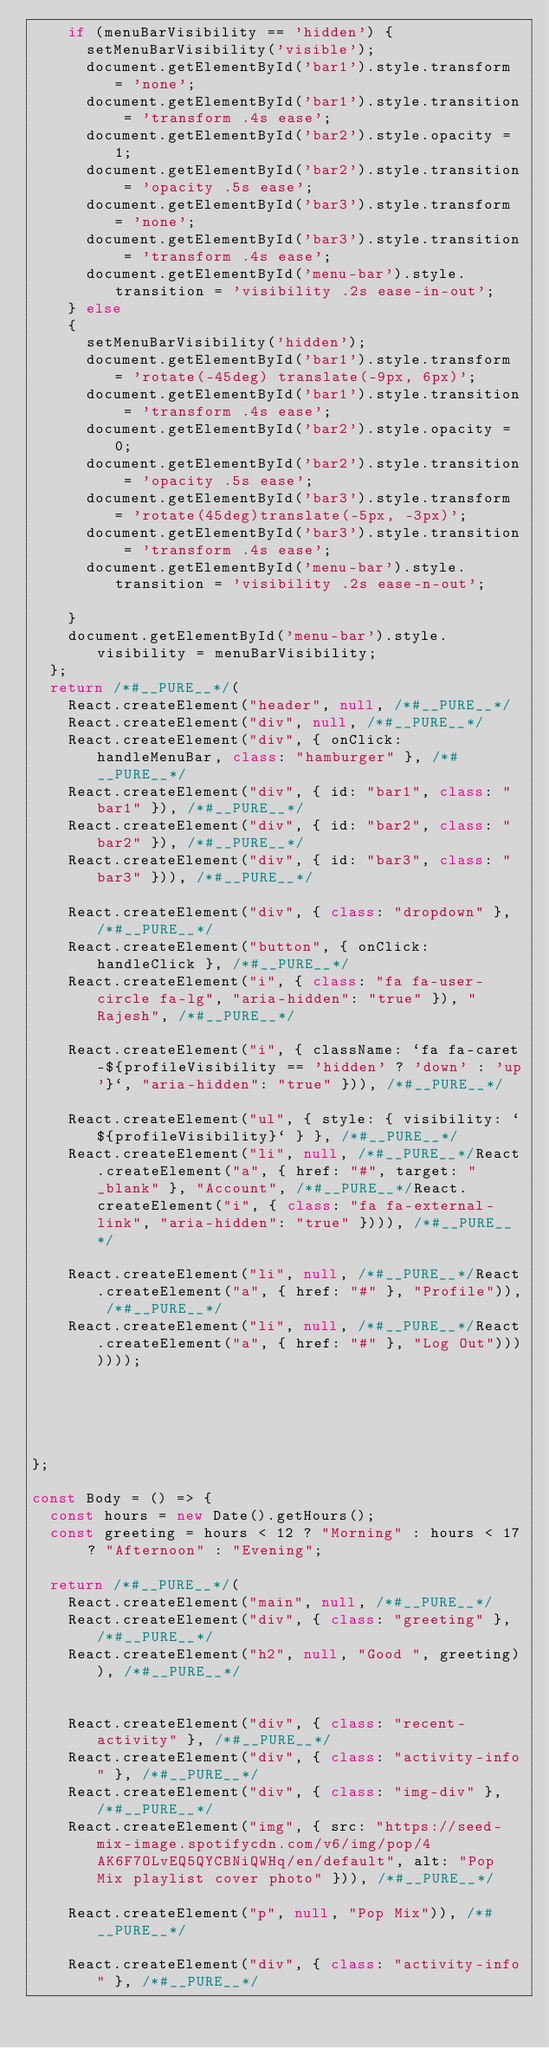Convert code to text. <code><loc_0><loc_0><loc_500><loc_500><_JavaScript_>    if (menuBarVisibility == 'hidden') {
      setMenuBarVisibility('visible');
      document.getElementById('bar1').style.transform = 'none';
      document.getElementById('bar1').style.transition = 'transform .4s ease';
      document.getElementById('bar2').style.opacity = 1;
      document.getElementById('bar2').style.transition = 'opacity .5s ease';
      document.getElementById('bar3').style.transform = 'none';
      document.getElementById('bar3').style.transition = 'transform .4s ease';
      document.getElementById('menu-bar').style.transition = 'visibility .2s ease-in-out';
    } else
    {
      setMenuBarVisibility('hidden');
      document.getElementById('bar1').style.transform = 'rotate(-45deg) translate(-9px, 6px)';
      document.getElementById('bar1').style.transition = 'transform .4s ease';
      document.getElementById('bar2').style.opacity = 0;
      document.getElementById('bar2').style.transition = 'opacity .5s ease';
      document.getElementById('bar3').style.transform = 'rotate(45deg)translate(-5px, -3px)';
      document.getElementById('bar3').style.transition = 'transform .4s ease';
      document.getElementById('menu-bar').style.transition = 'visibility .2s ease-n-out';

    }
    document.getElementById('menu-bar').style.visibility = menuBarVisibility;
  };
  return /*#__PURE__*/(
    React.createElement("header", null, /*#__PURE__*/
    React.createElement("div", null, /*#__PURE__*/
    React.createElement("div", { onClick: handleMenuBar, class: "hamburger" }, /*#__PURE__*/
    React.createElement("div", { id: "bar1", class: "bar1" }), /*#__PURE__*/
    React.createElement("div", { id: "bar2", class: "bar2" }), /*#__PURE__*/
    React.createElement("div", { id: "bar3", class: "bar3" })), /*#__PURE__*/

    React.createElement("div", { class: "dropdown" }, /*#__PURE__*/
    React.createElement("button", { onClick: handleClick }, /*#__PURE__*/
    React.createElement("i", { class: "fa fa-user-circle fa-lg", "aria-hidden": "true" }), "Rajesh", /*#__PURE__*/

    React.createElement("i", { className: `fa fa-caret-${profileVisibility == 'hidden' ? 'down' : 'up'}`, "aria-hidden": "true" })), /*#__PURE__*/

    React.createElement("ul", { style: { visibility: `${profileVisibility}` } }, /*#__PURE__*/
    React.createElement("li", null, /*#__PURE__*/React.createElement("a", { href: "#", target: "_blank" }, "Account", /*#__PURE__*/React.createElement("i", { class: "fa fa-external-link", "aria-hidden": "true" }))), /*#__PURE__*/

    React.createElement("li", null, /*#__PURE__*/React.createElement("a", { href: "#" }, "Profile")), /*#__PURE__*/
    React.createElement("li", null, /*#__PURE__*/React.createElement("a", { href: "#" }, "Log Out")))))));





};

const Body = () => {
  const hours = new Date().getHours();
  const greeting = hours < 12 ? "Morning" : hours < 17 ? "Afternoon" : "Evening";

  return /*#__PURE__*/(
    React.createElement("main", null, /*#__PURE__*/
    React.createElement("div", { class: "greeting" }, /*#__PURE__*/
    React.createElement("h2", null, "Good ", greeting)), /*#__PURE__*/


    React.createElement("div", { class: "recent-activity" }, /*#__PURE__*/
    React.createElement("div", { class: "activity-info" }, /*#__PURE__*/
    React.createElement("div", { class: "img-div" }, /*#__PURE__*/
    React.createElement("img", { src: "https://seed-mix-image.spotifycdn.com/v6/img/pop/4AK6F7OLvEQ5QYCBNiQWHq/en/default", alt: "Pop Mix playlist cover photo" })), /*#__PURE__*/

    React.createElement("p", null, "Pop Mix")), /*#__PURE__*/

    React.createElement("div", { class: "activity-info" }, /*#__PURE__*/</code> 